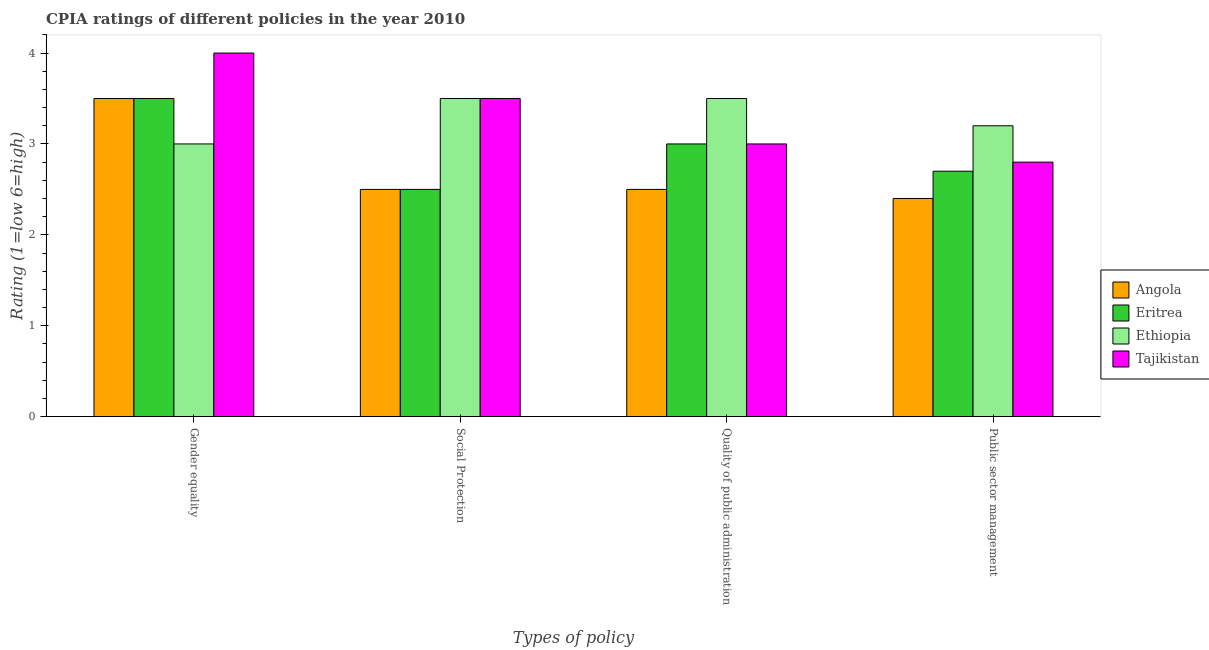Are the number of bars per tick equal to the number of legend labels?
Offer a very short reply. Yes. What is the label of the 2nd group of bars from the left?
Your response must be concise. Social Protection. What is the cpia rating of gender equality in Ethiopia?
Your answer should be compact. 3. Across all countries, what is the maximum cpia rating of social protection?
Offer a very short reply. 3.5. Across all countries, what is the minimum cpia rating of gender equality?
Keep it short and to the point. 3. In which country was the cpia rating of gender equality maximum?
Ensure brevity in your answer.  Tajikistan. In which country was the cpia rating of social protection minimum?
Your answer should be very brief. Angola. What is the total cpia rating of gender equality in the graph?
Offer a very short reply. 14. What is the difference between the cpia rating of gender equality in Angola and the cpia rating of public sector management in Eritrea?
Offer a terse response. 0.8. What is the average cpia rating of public sector management per country?
Give a very brief answer. 2.78. What is the difference between the cpia rating of social protection and cpia rating of public sector management in Eritrea?
Your answer should be very brief. -0.2. Is the cpia rating of social protection in Angola less than that in Ethiopia?
Provide a succinct answer. Yes. Is the difference between the cpia rating of gender equality in Angola and Tajikistan greater than the difference between the cpia rating of quality of public administration in Angola and Tajikistan?
Your answer should be compact. No. What is the difference between the highest and the lowest cpia rating of quality of public administration?
Your answer should be very brief. 1. In how many countries, is the cpia rating of public sector management greater than the average cpia rating of public sector management taken over all countries?
Provide a short and direct response. 2. Is the sum of the cpia rating of public sector management in Tajikistan and Ethiopia greater than the maximum cpia rating of social protection across all countries?
Make the answer very short. Yes. Is it the case that in every country, the sum of the cpia rating of quality of public administration and cpia rating of gender equality is greater than the sum of cpia rating of social protection and cpia rating of public sector management?
Ensure brevity in your answer.  Yes. What does the 1st bar from the left in Social Protection represents?
Provide a succinct answer. Angola. What does the 2nd bar from the right in Gender equality represents?
Ensure brevity in your answer.  Ethiopia. How many bars are there?
Your response must be concise. 16. What is the difference between two consecutive major ticks on the Y-axis?
Offer a terse response. 1. How are the legend labels stacked?
Offer a terse response. Vertical. What is the title of the graph?
Your answer should be very brief. CPIA ratings of different policies in the year 2010. Does "Guinea-Bissau" appear as one of the legend labels in the graph?
Offer a very short reply. No. What is the label or title of the X-axis?
Your answer should be very brief. Types of policy. What is the label or title of the Y-axis?
Give a very brief answer. Rating (1=low 6=high). What is the Rating (1=low 6=high) in Angola in Gender equality?
Offer a very short reply. 3.5. What is the Rating (1=low 6=high) in Eritrea in Social Protection?
Your answer should be compact. 2.5. What is the Rating (1=low 6=high) of Eritrea in Quality of public administration?
Provide a succinct answer. 3. What is the Rating (1=low 6=high) in Ethiopia in Quality of public administration?
Your response must be concise. 3.5. What is the Rating (1=low 6=high) in Angola in Public sector management?
Make the answer very short. 2.4. What is the Rating (1=low 6=high) in Eritrea in Public sector management?
Give a very brief answer. 2.7. Across all Types of policy, what is the maximum Rating (1=low 6=high) in Eritrea?
Give a very brief answer. 3.5. Across all Types of policy, what is the maximum Rating (1=low 6=high) of Tajikistan?
Your answer should be compact. 4. Across all Types of policy, what is the minimum Rating (1=low 6=high) in Angola?
Offer a very short reply. 2.4. Across all Types of policy, what is the minimum Rating (1=low 6=high) of Eritrea?
Give a very brief answer. 2.5. Across all Types of policy, what is the minimum Rating (1=low 6=high) in Ethiopia?
Make the answer very short. 3. What is the total Rating (1=low 6=high) in Angola in the graph?
Your response must be concise. 10.9. What is the difference between the Rating (1=low 6=high) in Eritrea in Gender equality and that in Quality of public administration?
Make the answer very short. 0.5. What is the difference between the Rating (1=low 6=high) of Ethiopia in Gender equality and that in Quality of public administration?
Ensure brevity in your answer.  -0.5. What is the difference between the Rating (1=low 6=high) in Ethiopia in Gender equality and that in Public sector management?
Your answer should be compact. -0.2. What is the difference between the Rating (1=low 6=high) of Tajikistan in Gender equality and that in Public sector management?
Make the answer very short. 1.2. What is the difference between the Rating (1=low 6=high) of Ethiopia in Social Protection and that in Quality of public administration?
Give a very brief answer. 0. What is the difference between the Rating (1=low 6=high) of Angola in Social Protection and that in Public sector management?
Offer a terse response. 0.1. What is the difference between the Rating (1=low 6=high) in Angola in Quality of public administration and that in Public sector management?
Your answer should be very brief. 0.1. What is the difference between the Rating (1=low 6=high) of Tajikistan in Quality of public administration and that in Public sector management?
Make the answer very short. 0.2. What is the difference between the Rating (1=low 6=high) in Angola in Gender equality and the Rating (1=low 6=high) in Ethiopia in Social Protection?
Provide a short and direct response. 0. What is the difference between the Rating (1=low 6=high) of Eritrea in Gender equality and the Rating (1=low 6=high) of Ethiopia in Social Protection?
Keep it short and to the point. 0. What is the difference between the Rating (1=low 6=high) of Eritrea in Gender equality and the Rating (1=low 6=high) of Tajikistan in Social Protection?
Make the answer very short. 0. What is the difference between the Rating (1=low 6=high) in Ethiopia in Gender equality and the Rating (1=low 6=high) in Tajikistan in Social Protection?
Offer a terse response. -0.5. What is the difference between the Rating (1=low 6=high) of Angola in Gender equality and the Rating (1=low 6=high) of Eritrea in Quality of public administration?
Provide a short and direct response. 0.5. What is the difference between the Rating (1=low 6=high) in Angola in Gender equality and the Rating (1=low 6=high) in Ethiopia in Quality of public administration?
Offer a very short reply. 0. What is the difference between the Rating (1=low 6=high) of Angola in Gender equality and the Rating (1=low 6=high) of Tajikistan in Quality of public administration?
Provide a succinct answer. 0.5. What is the difference between the Rating (1=low 6=high) in Angola in Gender equality and the Rating (1=low 6=high) in Eritrea in Public sector management?
Offer a terse response. 0.8. What is the difference between the Rating (1=low 6=high) of Angola in Gender equality and the Rating (1=low 6=high) of Ethiopia in Public sector management?
Offer a terse response. 0.3. What is the difference between the Rating (1=low 6=high) in Eritrea in Gender equality and the Rating (1=low 6=high) in Tajikistan in Public sector management?
Your response must be concise. 0.7. What is the difference between the Rating (1=low 6=high) in Ethiopia in Gender equality and the Rating (1=low 6=high) in Tajikistan in Public sector management?
Offer a terse response. 0.2. What is the difference between the Rating (1=low 6=high) of Angola in Social Protection and the Rating (1=low 6=high) of Tajikistan in Quality of public administration?
Your response must be concise. -0.5. What is the difference between the Rating (1=low 6=high) of Eritrea in Social Protection and the Rating (1=low 6=high) of Ethiopia in Quality of public administration?
Offer a very short reply. -1. What is the difference between the Rating (1=low 6=high) in Ethiopia in Social Protection and the Rating (1=low 6=high) in Tajikistan in Quality of public administration?
Provide a short and direct response. 0.5. What is the difference between the Rating (1=low 6=high) of Angola in Social Protection and the Rating (1=low 6=high) of Eritrea in Public sector management?
Keep it short and to the point. -0.2. What is the difference between the Rating (1=low 6=high) in Angola in Social Protection and the Rating (1=low 6=high) in Tajikistan in Public sector management?
Offer a terse response. -0.3. What is the difference between the Rating (1=low 6=high) in Angola in Quality of public administration and the Rating (1=low 6=high) in Eritrea in Public sector management?
Ensure brevity in your answer.  -0.2. What is the difference between the Rating (1=low 6=high) in Angola in Quality of public administration and the Rating (1=low 6=high) in Ethiopia in Public sector management?
Provide a short and direct response. -0.7. What is the difference between the Rating (1=low 6=high) in Angola in Quality of public administration and the Rating (1=low 6=high) in Tajikistan in Public sector management?
Make the answer very short. -0.3. What is the average Rating (1=low 6=high) of Angola per Types of policy?
Provide a short and direct response. 2.73. What is the average Rating (1=low 6=high) of Eritrea per Types of policy?
Make the answer very short. 2.92. What is the average Rating (1=low 6=high) of Ethiopia per Types of policy?
Your answer should be compact. 3.3. What is the average Rating (1=low 6=high) in Tajikistan per Types of policy?
Provide a succinct answer. 3.33. What is the difference between the Rating (1=low 6=high) of Angola and Rating (1=low 6=high) of Eritrea in Gender equality?
Your answer should be compact. 0. What is the difference between the Rating (1=low 6=high) of Eritrea and Rating (1=low 6=high) of Ethiopia in Social Protection?
Offer a terse response. -1. What is the difference between the Rating (1=low 6=high) in Eritrea and Rating (1=low 6=high) in Tajikistan in Social Protection?
Your response must be concise. -1. What is the difference between the Rating (1=low 6=high) of Angola and Rating (1=low 6=high) of Eritrea in Quality of public administration?
Your response must be concise. -0.5. What is the difference between the Rating (1=low 6=high) in Angola and Rating (1=low 6=high) in Tajikistan in Quality of public administration?
Offer a very short reply. -0.5. What is the difference between the Rating (1=low 6=high) in Eritrea and Rating (1=low 6=high) in Ethiopia in Quality of public administration?
Keep it short and to the point. -0.5. What is the difference between the Rating (1=low 6=high) in Eritrea and Rating (1=low 6=high) in Tajikistan in Quality of public administration?
Your answer should be compact. 0. What is the difference between the Rating (1=low 6=high) of Ethiopia and Rating (1=low 6=high) of Tajikistan in Quality of public administration?
Ensure brevity in your answer.  0.5. What is the difference between the Rating (1=low 6=high) of Angola and Rating (1=low 6=high) of Ethiopia in Public sector management?
Ensure brevity in your answer.  -0.8. What is the difference between the Rating (1=low 6=high) of Angola and Rating (1=low 6=high) of Tajikistan in Public sector management?
Provide a short and direct response. -0.4. What is the difference between the Rating (1=low 6=high) of Eritrea and Rating (1=low 6=high) of Ethiopia in Public sector management?
Your answer should be very brief. -0.5. What is the difference between the Rating (1=low 6=high) of Eritrea and Rating (1=low 6=high) of Tajikistan in Public sector management?
Your response must be concise. -0.1. What is the difference between the Rating (1=low 6=high) in Ethiopia and Rating (1=low 6=high) in Tajikistan in Public sector management?
Offer a very short reply. 0.4. What is the ratio of the Rating (1=low 6=high) in Angola in Gender equality to that in Social Protection?
Your answer should be very brief. 1.4. What is the ratio of the Rating (1=low 6=high) in Eritrea in Gender equality to that in Quality of public administration?
Provide a short and direct response. 1.17. What is the ratio of the Rating (1=low 6=high) of Angola in Gender equality to that in Public sector management?
Give a very brief answer. 1.46. What is the ratio of the Rating (1=low 6=high) in Eritrea in Gender equality to that in Public sector management?
Provide a succinct answer. 1.3. What is the ratio of the Rating (1=low 6=high) in Ethiopia in Gender equality to that in Public sector management?
Make the answer very short. 0.94. What is the ratio of the Rating (1=low 6=high) of Tajikistan in Gender equality to that in Public sector management?
Keep it short and to the point. 1.43. What is the ratio of the Rating (1=low 6=high) of Tajikistan in Social Protection to that in Quality of public administration?
Offer a very short reply. 1.17. What is the ratio of the Rating (1=low 6=high) in Angola in Social Protection to that in Public sector management?
Keep it short and to the point. 1.04. What is the ratio of the Rating (1=low 6=high) in Eritrea in Social Protection to that in Public sector management?
Offer a very short reply. 0.93. What is the ratio of the Rating (1=low 6=high) in Ethiopia in Social Protection to that in Public sector management?
Offer a very short reply. 1.09. What is the ratio of the Rating (1=low 6=high) in Angola in Quality of public administration to that in Public sector management?
Give a very brief answer. 1.04. What is the ratio of the Rating (1=low 6=high) of Ethiopia in Quality of public administration to that in Public sector management?
Your answer should be very brief. 1.09. What is the ratio of the Rating (1=low 6=high) in Tajikistan in Quality of public administration to that in Public sector management?
Offer a very short reply. 1.07. What is the difference between the highest and the second highest Rating (1=low 6=high) in Eritrea?
Make the answer very short. 0.5. 